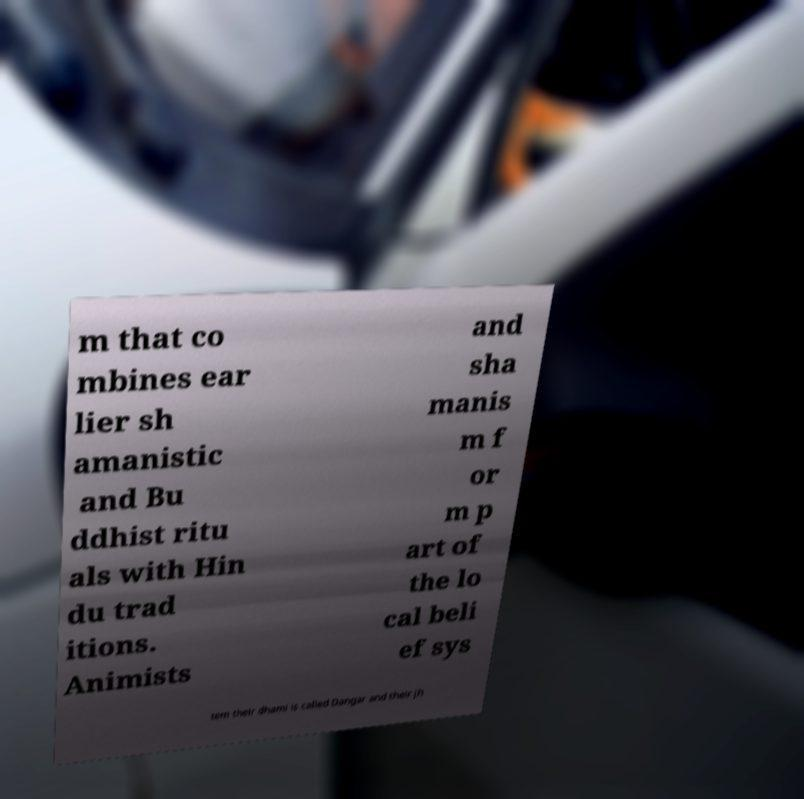For documentation purposes, I need the text within this image transcribed. Could you provide that? m that co mbines ear lier sh amanistic and Bu ddhist ritu als with Hin du trad itions. Animists and sha manis m f or m p art of the lo cal beli ef sys tem their dhami is called Dangar and their jh 